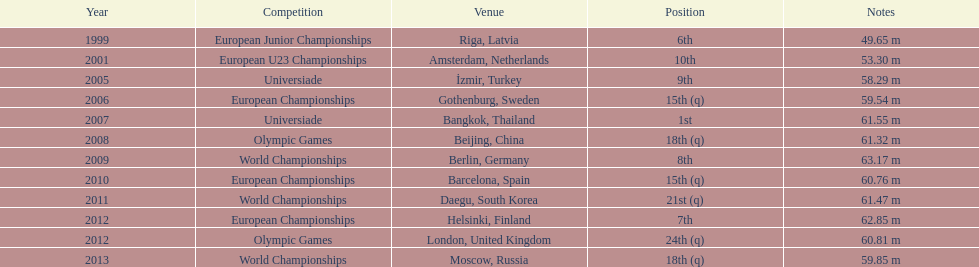Before 2007, what was the top position attained? 6th. 